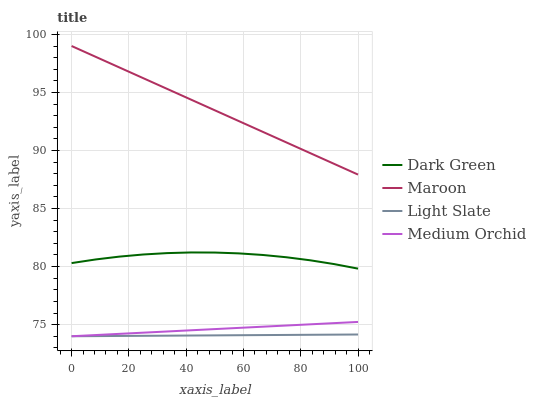Does Light Slate have the minimum area under the curve?
Answer yes or no. Yes. Does Maroon have the maximum area under the curve?
Answer yes or no. Yes. Does Medium Orchid have the minimum area under the curve?
Answer yes or no. No. Does Medium Orchid have the maximum area under the curve?
Answer yes or no. No. Is Light Slate the smoothest?
Answer yes or no. Yes. Is Dark Green the roughest?
Answer yes or no. Yes. Is Medium Orchid the smoothest?
Answer yes or no. No. Is Medium Orchid the roughest?
Answer yes or no. No. Does Light Slate have the lowest value?
Answer yes or no. Yes. Does Maroon have the lowest value?
Answer yes or no. No. Does Maroon have the highest value?
Answer yes or no. Yes. Does Medium Orchid have the highest value?
Answer yes or no. No. Is Dark Green less than Maroon?
Answer yes or no. Yes. Is Dark Green greater than Light Slate?
Answer yes or no. Yes. Does Light Slate intersect Medium Orchid?
Answer yes or no. Yes. Is Light Slate less than Medium Orchid?
Answer yes or no. No. Is Light Slate greater than Medium Orchid?
Answer yes or no. No. Does Dark Green intersect Maroon?
Answer yes or no. No. 